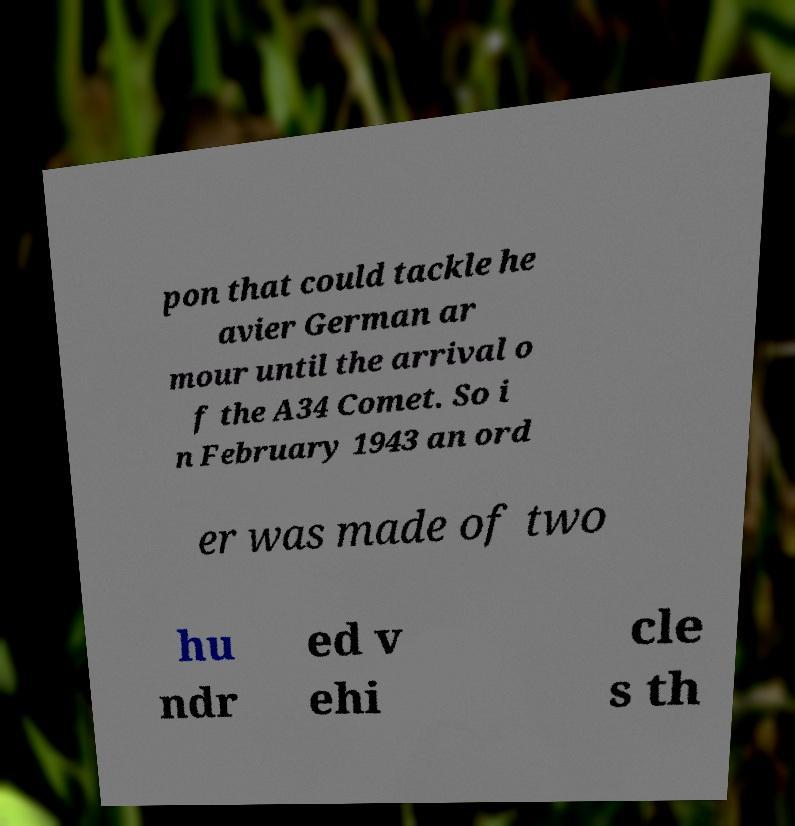There's text embedded in this image that I need extracted. Can you transcribe it verbatim? pon that could tackle he avier German ar mour until the arrival o f the A34 Comet. So i n February 1943 an ord er was made of two hu ndr ed v ehi cle s th 